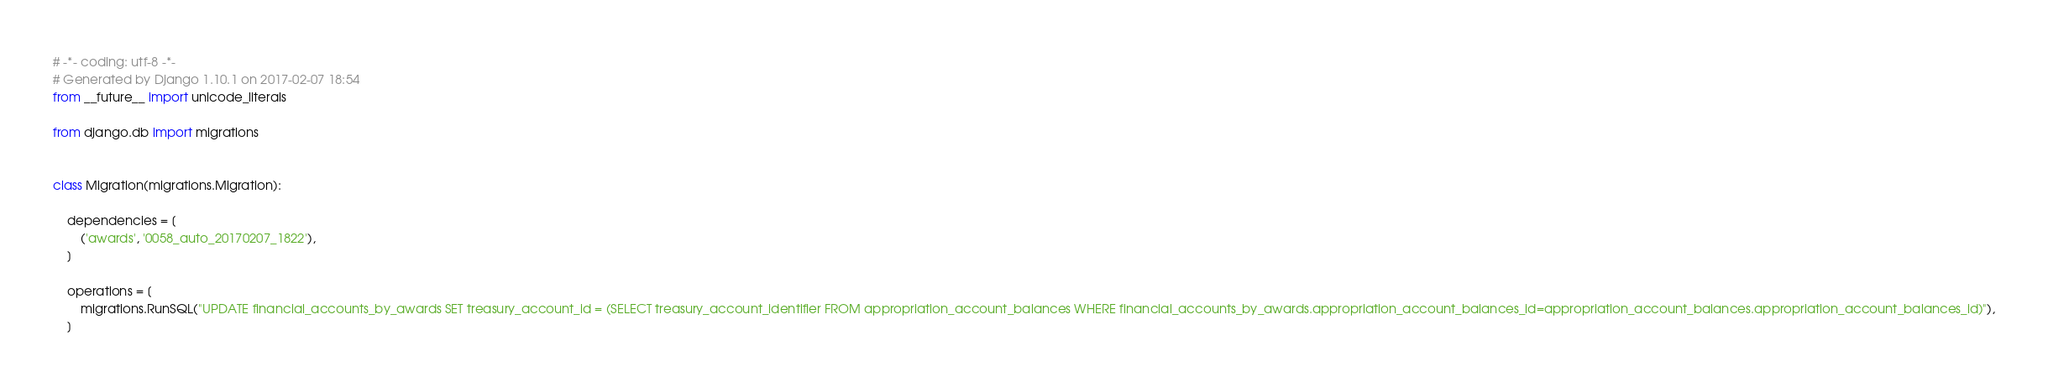<code> <loc_0><loc_0><loc_500><loc_500><_Python_># -*- coding: utf-8 -*-
# Generated by Django 1.10.1 on 2017-02-07 18:54
from __future__ import unicode_literals

from django.db import migrations


class Migration(migrations.Migration):

    dependencies = [
        ('awards', '0058_auto_20170207_1822'),
    ]

    operations = [
        migrations.RunSQL("UPDATE financial_accounts_by_awards SET treasury_account_id = (SELECT treasury_account_identifier FROM appropriation_account_balances WHERE financial_accounts_by_awards.appropriation_account_balances_id=appropriation_account_balances.appropriation_account_balances_id)"),
    ]
</code> 